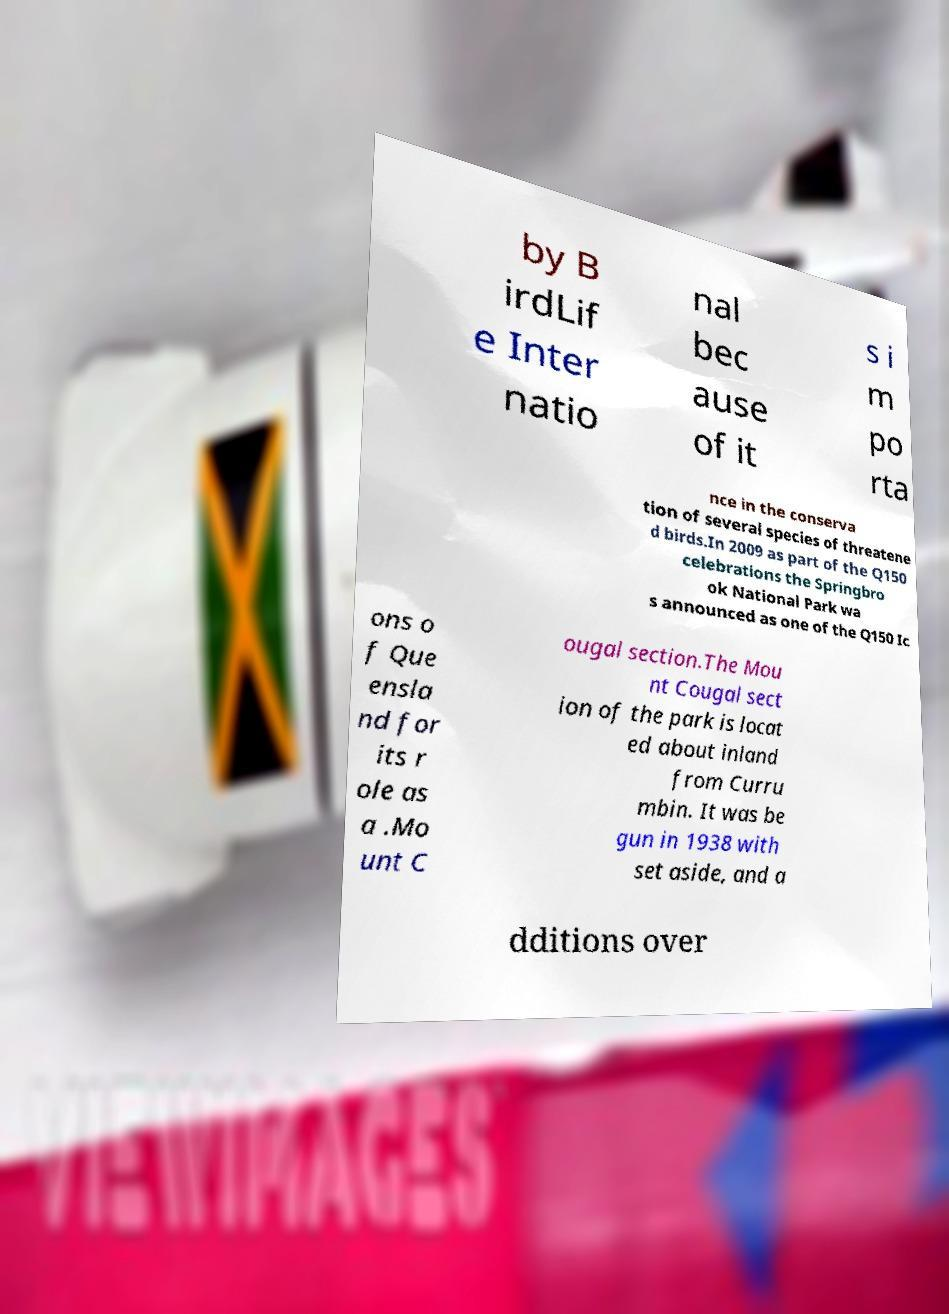There's text embedded in this image that I need extracted. Can you transcribe it verbatim? by B irdLif e Inter natio nal bec ause of it s i m po rta nce in the conserva tion of several species of threatene d birds.In 2009 as part of the Q150 celebrations the Springbro ok National Park wa s announced as one of the Q150 Ic ons o f Que ensla nd for its r ole as a .Mo unt C ougal section.The Mou nt Cougal sect ion of the park is locat ed about inland from Curru mbin. It was be gun in 1938 with set aside, and a dditions over 